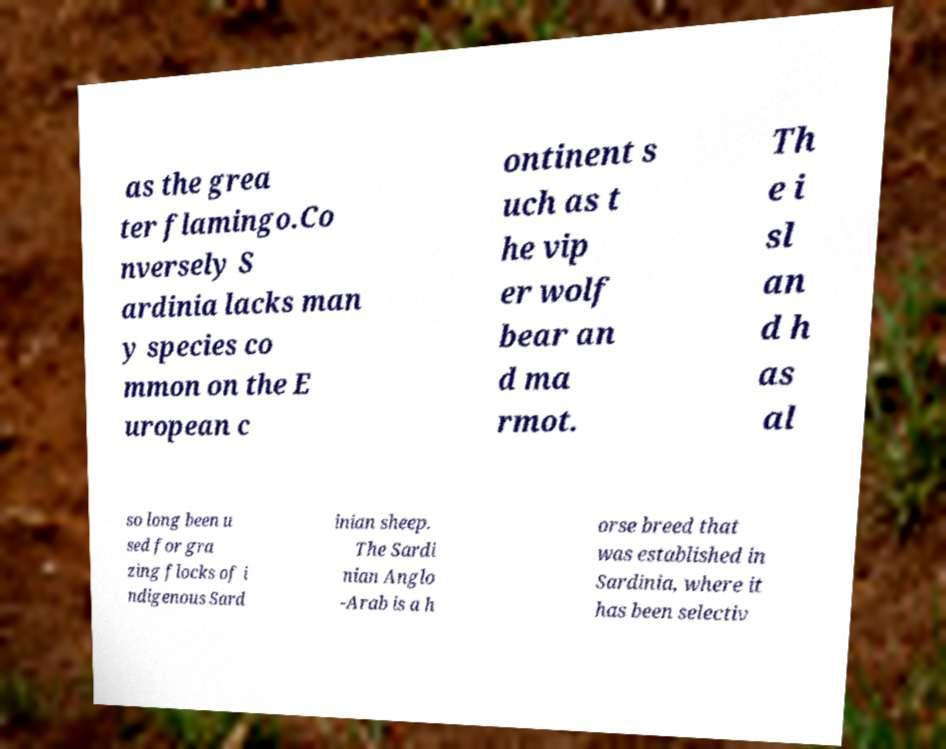Could you assist in decoding the text presented in this image and type it out clearly? as the grea ter flamingo.Co nversely S ardinia lacks man y species co mmon on the E uropean c ontinent s uch as t he vip er wolf bear an d ma rmot. Th e i sl an d h as al so long been u sed for gra zing flocks of i ndigenous Sard inian sheep. The Sardi nian Anglo -Arab is a h orse breed that was established in Sardinia, where it has been selectiv 